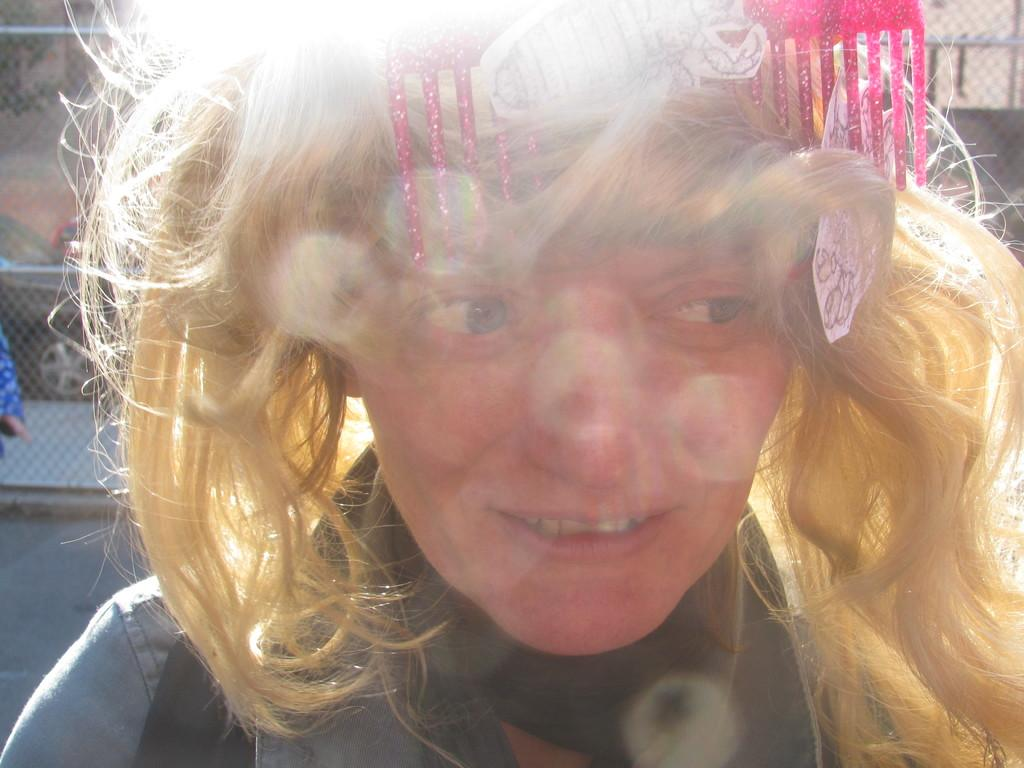Who is present in the image? There is a woman in the image. What is the woman wearing on her head? The woman is wearing a comb on her head. What can be seen in the background of the image? There is a fence in the background of the image. What other objects can be seen in the image? There are other objects visible in the image, but their specific details are not mentioned in the provided facts. What type of wind can be seen blowing through the image? There is no wind visible in the image; it is a still image. What happens to the fence when the tank drives through the image? There is no tank present in the image, so the fence is not affected by any vehicle. 